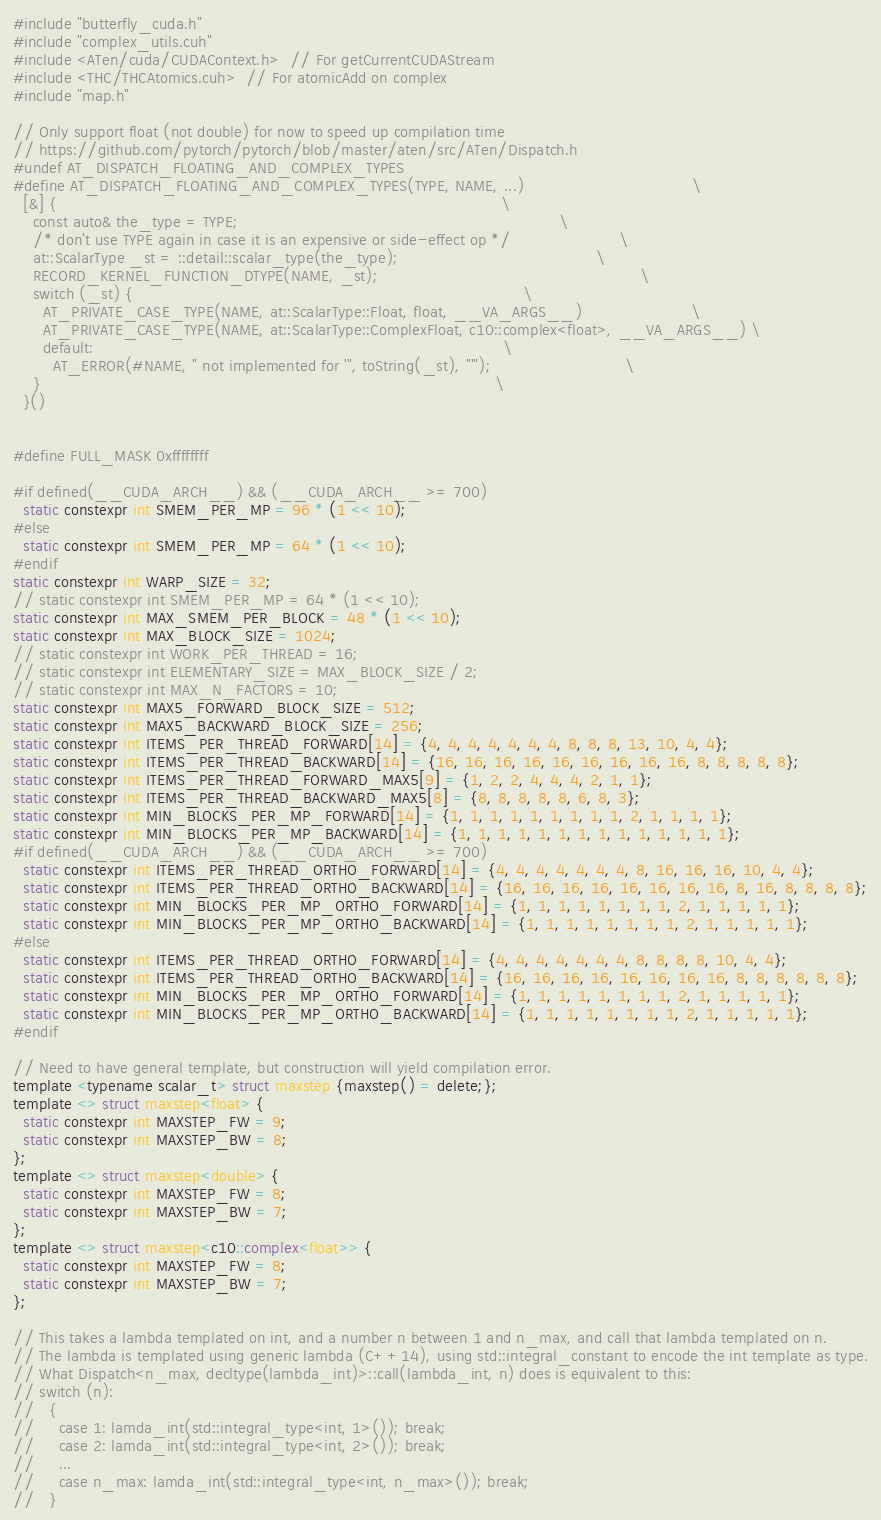<code> <loc_0><loc_0><loc_500><loc_500><_Cuda_>#include "butterfly_cuda.h"
#include "complex_utils.cuh"
#include <ATen/cuda/CUDAContext.h>  // For getCurrentCUDAStream
#include <THC/THCAtomics.cuh>  // For atomicAdd on complex
#include "map.h"

// Only support float (not double) for now to speed up compilation time
// https://github.com/pytorch/pytorch/blob/master/aten/src/ATen/Dispatch.h
#undef AT_DISPATCH_FLOATING_AND_COMPLEX_TYPES
#define AT_DISPATCH_FLOATING_AND_COMPLEX_TYPES(TYPE, NAME, ...)                                  \
  [&] {                                                                                          \
    const auto& the_type = TYPE;                                                                 \
    /* don't use TYPE again in case it is an expensive or side-effect op */                      \
    at::ScalarType _st = ::detail::scalar_type(the_type);                                        \
    RECORD_KERNEL_FUNCTION_DTYPE(NAME, _st);                                                     \
    switch (_st) {                                                                               \
      AT_PRIVATE_CASE_TYPE(NAME, at::ScalarType::Float, float, __VA_ARGS__)                      \
      AT_PRIVATE_CASE_TYPE(NAME, at::ScalarType::ComplexFloat, c10::complex<float>, __VA_ARGS__) \
      default:                                                                                   \
        AT_ERROR(#NAME, " not implemented for '", toString(_st), "'");                           \
    }                                                                                            \
  }()


#define FULL_MASK 0xffffffff

#if defined(__CUDA_ARCH__) && (__CUDA_ARCH__ >= 700)
  static constexpr int SMEM_PER_MP = 96 * (1 << 10);
#else
  static constexpr int SMEM_PER_MP = 64 * (1 << 10);
#endif
static constexpr int WARP_SIZE = 32;
// static constexpr int SMEM_PER_MP = 64 * (1 << 10);
static constexpr int MAX_SMEM_PER_BLOCK = 48 * (1 << 10);
static constexpr int MAX_BLOCK_SIZE = 1024;
// static constexpr int WORK_PER_THREAD = 16;
// static constexpr int ELEMENTARY_SIZE = MAX_BLOCK_SIZE / 2;
// static constexpr int MAX_N_FACTORS = 10;
static constexpr int MAX5_FORWARD_BLOCK_SIZE = 512;
static constexpr int MAX5_BACKWARD_BLOCK_SIZE = 256;
static constexpr int ITEMS_PER_THREAD_FORWARD[14] = {4, 4, 4, 4, 4, 4, 4, 8, 8, 8, 13, 10, 4, 4};
static constexpr int ITEMS_PER_THREAD_BACKWARD[14] = {16, 16, 16, 16, 16, 16, 16, 16, 16, 8, 8, 8, 8, 8};
static constexpr int ITEMS_PER_THREAD_FORWARD_MAX5[9] = {1, 2, 2, 4, 4, 4, 2, 1, 1};
static constexpr int ITEMS_PER_THREAD_BACKWARD_MAX5[8] = {8, 8, 8, 8, 8, 6, 8, 3};
static constexpr int MIN_BLOCKS_PER_MP_FORWARD[14] = {1, 1, 1, 1, 1, 1, 1, 1, 1, 2, 1, 1, 1, 1};
static constexpr int MIN_BLOCKS_PER_MP_BACKWARD[14] = {1, 1, 1, 1, 1, 1, 1, 1, 1, 1, 1, 1, 1, 1};
#if defined(__CUDA_ARCH__) && (__CUDA_ARCH__ >= 700)
  static constexpr int ITEMS_PER_THREAD_ORTHO_FORWARD[14] = {4, 4, 4, 4, 4, 4, 4, 8, 16, 16, 16, 10, 4, 4};
  static constexpr int ITEMS_PER_THREAD_ORTHO_BACKWARD[14] = {16, 16, 16, 16, 16, 16, 16, 16, 8, 16, 8, 8, 8, 8};
  static constexpr int MIN_BLOCKS_PER_MP_ORTHO_FORWARD[14] = {1, 1, 1, 1, 1, 1, 1, 1, 2, 1, 1, 1, 1, 1};
  static constexpr int MIN_BLOCKS_PER_MP_ORTHO_BACKWARD[14] = {1, 1, 1, 1, 1, 1, 1, 1, 2, 1, 1, 1, 1, 1};
#else
  static constexpr int ITEMS_PER_THREAD_ORTHO_FORWARD[14] = {4, 4, 4, 4, 4, 4, 4, 8, 8, 8, 8, 10, 4, 4};
  static constexpr int ITEMS_PER_THREAD_ORTHO_BACKWARD[14] = {16, 16, 16, 16, 16, 16, 16, 16, 8, 8, 8, 8, 8, 8};
  static constexpr int MIN_BLOCKS_PER_MP_ORTHO_FORWARD[14] = {1, 1, 1, 1, 1, 1, 1, 1, 2, 1, 1, 1, 1, 1};
  static constexpr int MIN_BLOCKS_PER_MP_ORTHO_BACKWARD[14] = {1, 1, 1, 1, 1, 1, 1, 1, 2, 1, 1, 1, 1, 1};
#endif

// Need to have general template, but construction will yield compilation error.
template <typename scalar_t> struct maxstep {maxstep() = delete;};
template <> struct maxstep<float> {
  static constexpr int MAXSTEP_FW = 9;
  static constexpr int MAXSTEP_BW = 8;
};
template <> struct maxstep<double> {
  static constexpr int MAXSTEP_FW = 8;
  static constexpr int MAXSTEP_BW = 7;
};
template <> struct maxstep<c10::complex<float>> {
  static constexpr int MAXSTEP_FW = 8;
  static constexpr int MAXSTEP_BW = 7;
};

// This takes a lambda templated on int, and a number n between 1 and n_max, and call that lambda templated on n.
// The lambda is templated using generic lambda (C++14), using std::integral_constant to encode the int template as type.
// What Dispatch<n_max, decltype(lambda_int)>::call(lambda_int, n) does is equivalent to this:
// switch (n):
//   {
//     case 1: lamda_int(std::integral_type<int, 1>()); break;
//     case 2: lamda_int(std::integral_type<int, 2>()); break;
//     ...
//     case n_max: lamda_int(std::integral_type<int, n_max>()); break;
//   }</code> 